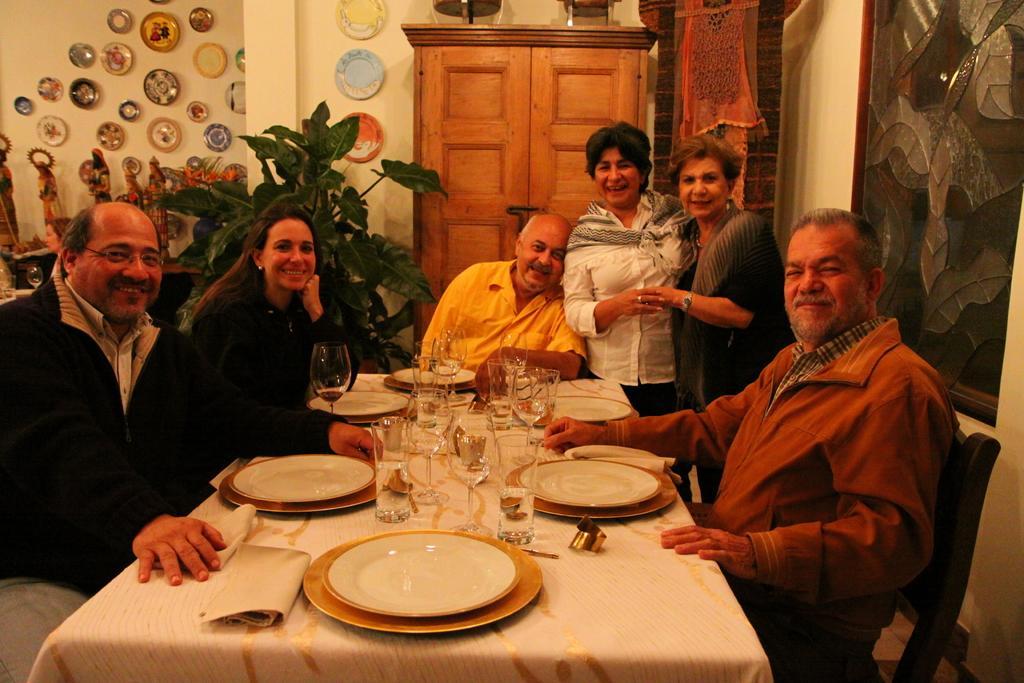Could you give a brief overview of what you see in this image? As we can see in the image there is a wall, door, few people sitting on chairs and a table. On table there are plates, glasses and cloth. 